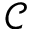<formula> <loc_0><loc_0><loc_500><loc_500>\ m a t h s c r { C }</formula> 